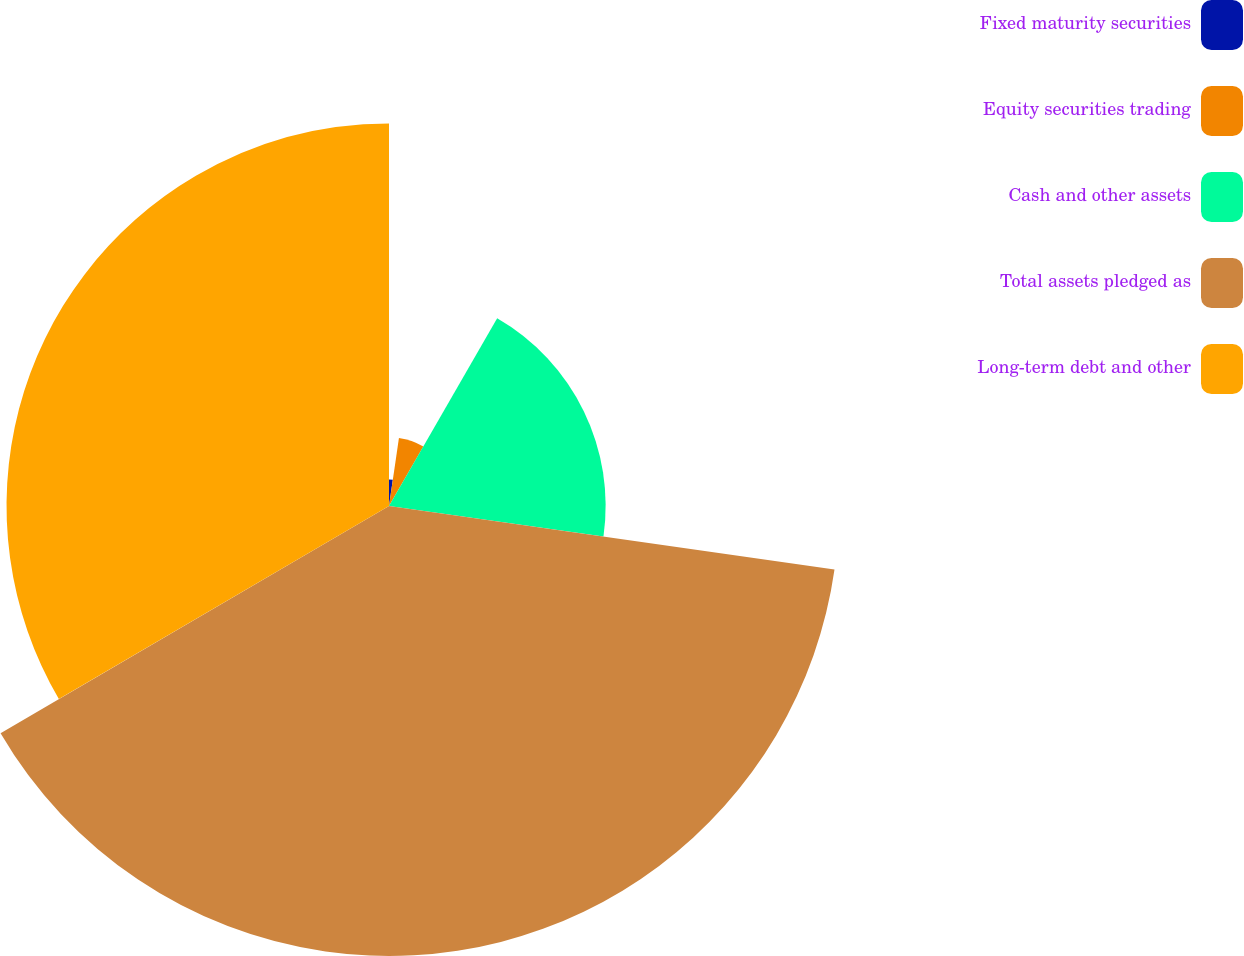Convert chart to OTSL. <chart><loc_0><loc_0><loc_500><loc_500><pie_chart><fcel>Fixed maturity securities<fcel>Equity securities trading<fcel>Cash and other assets<fcel>Total assets pledged as<fcel>Long-term debt and other<nl><fcel>2.31%<fcel>6.01%<fcel>18.93%<fcel>39.32%<fcel>33.42%<nl></chart> 